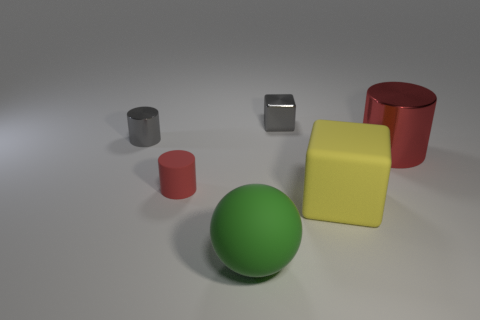Is there a green rubber sphere that has the same size as the gray metal cylinder?
Offer a very short reply. No. There is another object that is the same color as the large metal object; what is its shape?
Make the answer very short. Cylinder. What number of gray objects have the same size as the green thing?
Provide a short and direct response. 0. Do the metallic cylinder that is on the left side of the big shiny cylinder and the cube that is to the left of the yellow rubber thing have the same size?
Make the answer very short. Yes. How many things are either tiny yellow metal cylinders or cubes in front of the red metal object?
Your answer should be very brief. 1. What is the color of the tiny matte cylinder?
Make the answer very short. Red. There is a large object that is behind the cube that is to the right of the metallic object that is behind the small shiny cylinder; what is its material?
Your response must be concise. Metal. What size is the other cylinder that is the same material as the gray cylinder?
Your answer should be very brief. Large. Is there a thing that has the same color as the big cylinder?
Give a very brief answer. Yes. There is a gray shiny cylinder; does it have the same size as the metal object that is on the right side of the shiny cube?
Offer a very short reply. No. 